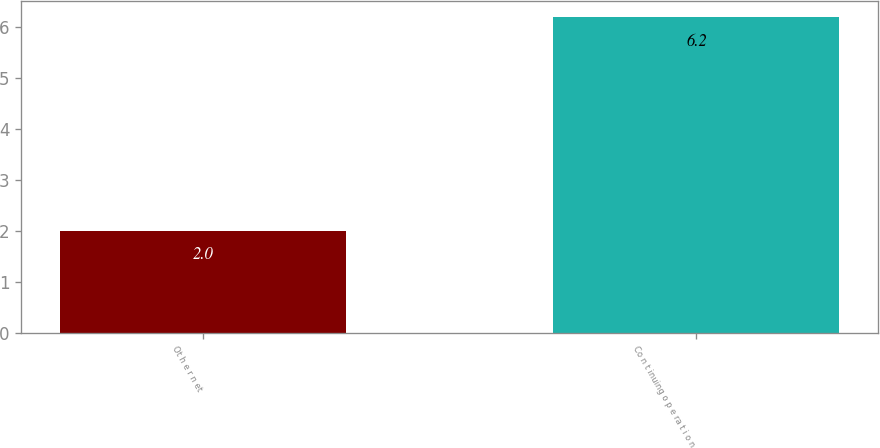<chart> <loc_0><loc_0><loc_500><loc_500><bar_chart><fcel>Ot h e r n et<fcel>Co n t inuing o p e ra t i o n<nl><fcel>2<fcel>6.2<nl></chart> 